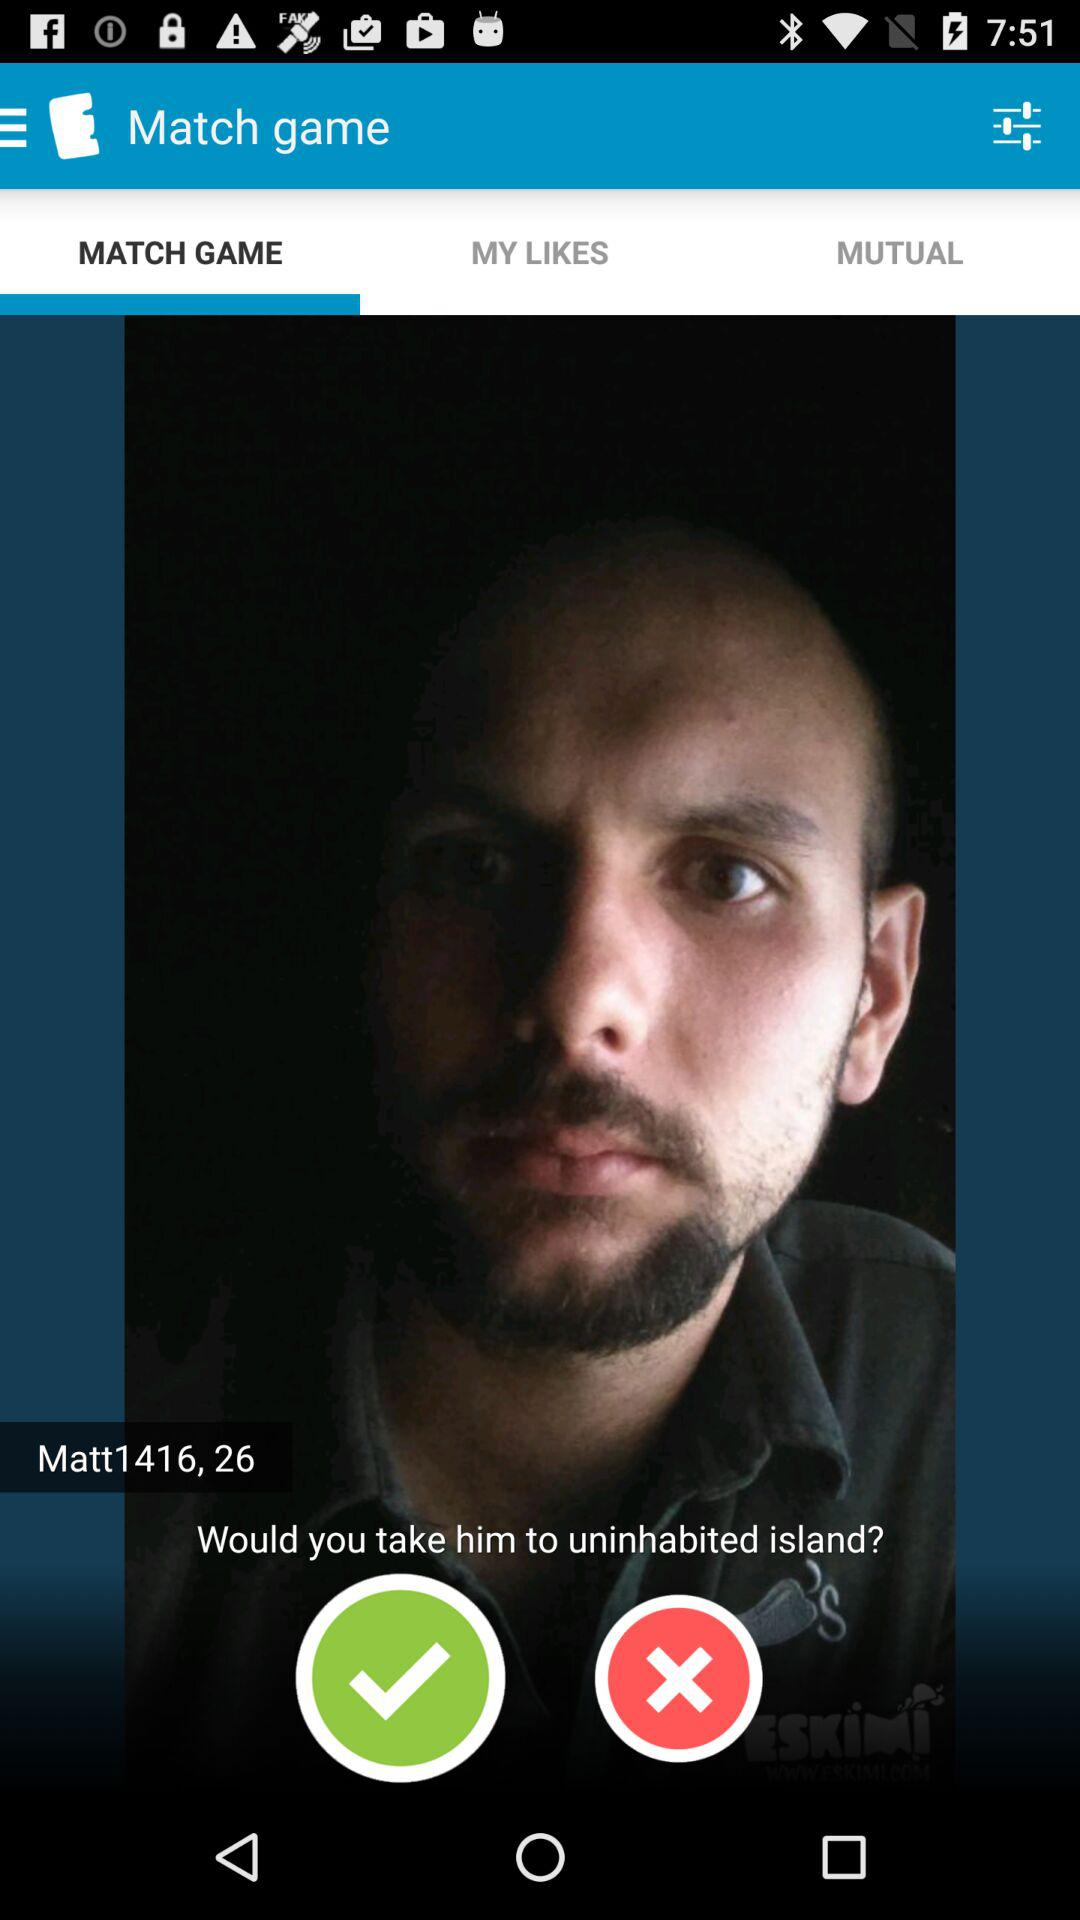What is the age of "Matt1416"? The age of "Matt1416" is 26. 